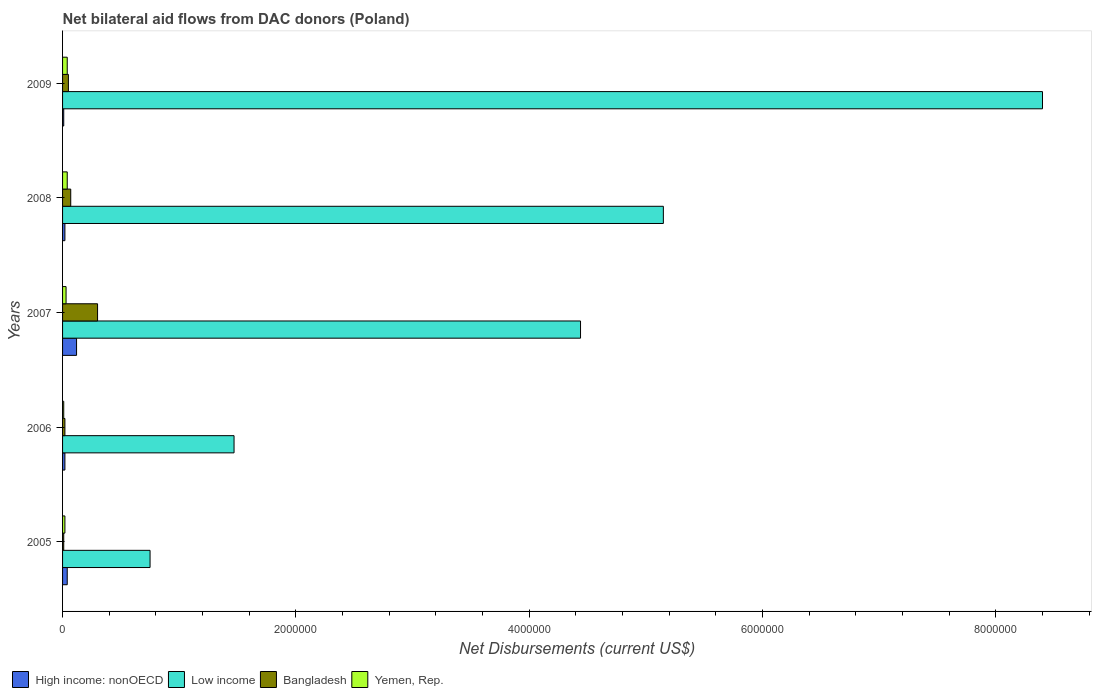How many different coloured bars are there?
Provide a short and direct response. 4. How many groups of bars are there?
Ensure brevity in your answer.  5. Are the number of bars per tick equal to the number of legend labels?
Provide a succinct answer. Yes. Are the number of bars on each tick of the Y-axis equal?
Your answer should be compact. Yes. How many bars are there on the 2nd tick from the bottom?
Your response must be concise. 4. What is the label of the 2nd group of bars from the top?
Offer a very short reply. 2008. In how many cases, is the number of bars for a given year not equal to the number of legend labels?
Provide a succinct answer. 0. What is the net bilateral aid flows in High income: nonOECD in 2005?
Offer a very short reply. 4.00e+04. Across all years, what is the maximum net bilateral aid flows in Low income?
Keep it short and to the point. 8.40e+06. Across all years, what is the minimum net bilateral aid flows in Low income?
Ensure brevity in your answer.  7.50e+05. In which year was the net bilateral aid flows in Bangladesh maximum?
Provide a succinct answer. 2007. What is the total net bilateral aid flows in Bangladesh in the graph?
Provide a succinct answer. 4.50e+05. What is the difference between the net bilateral aid flows in Yemen, Rep. in 2005 and that in 2008?
Your answer should be compact. -2.00e+04. What is the average net bilateral aid flows in High income: nonOECD per year?
Offer a terse response. 4.20e+04. In the year 2006, what is the difference between the net bilateral aid flows in High income: nonOECD and net bilateral aid flows in Low income?
Your answer should be compact. -1.45e+06. In how many years, is the net bilateral aid flows in Yemen, Rep. greater than 2000000 US$?
Provide a short and direct response. 0. Is the difference between the net bilateral aid flows in High income: nonOECD in 2006 and 2007 greater than the difference between the net bilateral aid flows in Low income in 2006 and 2007?
Make the answer very short. Yes. What is the difference between the highest and the lowest net bilateral aid flows in Low income?
Your response must be concise. 7.65e+06. Is the sum of the net bilateral aid flows in High income: nonOECD in 2006 and 2009 greater than the maximum net bilateral aid flows in Yemen, Rep. across all years?
Offer a terse response. No. Is it the case that in every year, the sum of the net bilateral aid flows in Yemen, Rep. and net bilateral aid flows in Bangladesh is greater than the sum of net bilateral aid flows in Low income and net bilateral aid flows in High income: nonOECD?
Provide a succinct answer. No. What does the 4th bar from the top in 2005 represents?
Make the answer very short. High income: nonOECD. What does the 1st bar from the bottom in 2005 represents?
Provide a succinct answer. High income: nonOECD. Is it the case that in every year, the sum of the net bilateral aid flows in High income: nonOECD and net bilateral aid flows in Low income is greater than the net bilateral aid flows in Bangladesh?
Keep it short and to the point. Yes. Are the values on the major ticks of X-axis written in scientific E-notation?
Offer a terse response. No. Does the graph contain grids?
Provide a succinct answer. No. How are the legend labels stacked?
Offer a very short reply. Horizontal. What is the title of the graph?
Your answer should be very brief. Net bilateral aid flows from DAC donors (Poland). What is the label or title of the X-axis?
Offer a very short reply. Net Disbursements (current US$). What is the label or title of the Y-axis?
Keep it short and to the point. Years. What is the Net Disbursements (current US$) of High income: nonOECD in 2005?
Keep it short and to the point. 4.00e+04. What is the Net Disbursements (current US$) in Low income in 2005?
Provide a succinct answer. 7.50e+05. What is the Net Disbursements (current US$) of Bangladesh in 2005?
Offer a very short reply. 10000. What is the Net Disbursements (current US$) of Yemen, Rep. in 2005?
Provide a succinct answer. 2.00e+04. What is the Net Disbursements (current US$) in High income: nonOECD in 2006?
Your response must be concise. 2.00e+04. What is the Net Disbursements (current US$) of Low income in 2006?
Your response must be concise. 1.47e+06. What is the Net Disbursements (current US$) of Yemen, Rep. in 2006?
Your answer should be compact. 10000. What is the Net Disbursements (current US$) in High income: nonOECD in 2007?
Give a very brief answer. 1.20e+05. What is the Net Disbursements (current US$) of Low income in 2007?
Your answer should be very brief. 4.44e+06. What is the Net Disbursements (current US$) in High income: nonOECD in 2008?
Provide a succinct answer. 2.00e+04. What is the Net Disbursements (current US$) in Low income in 2008?
Ensure brevity in your answer.  5.15e+06. What is the Net Disbursements (current US$) of Bangladesh in 2008?
Your answer should be very brief. 7.00e+04. What is the Net Disbursements (current US$) of High income: nonOECD in 2009?
Ensure brevity in your answer.  10000. What is the Net Disbursements (current US$) in Low income in 2009?
Make the answer very short. 8.40e+06. What is the Net Disbursements (current US$) of Yemen, Rep. in 2009?
Provide a short and direct response. 4.00e+04. Across all years, what is the maximum Net Disbursements (current US$) of High income: nonOECD?
Make the answer very short. 1.20e+05. Across all years, what is the maximum Net Disbursements (current US$) of Low income?
Your answer should be compact. 8.40e+06. Across all years, what is the maximum Net Disbursements (current US$) of Bangladesh?
Your response must be concise. 3.00e+05. Across all years, what is the minimum Net Disbursements (current US$) of High income: nonOECD?
Your response must be concise. 10000. Across all years, what is the minimum Net Disbursements (current US$) in Low income?
Give a very brief answer. 7.50e+05. Across all years, what is the minimum Net Disbursements (current US$) of Bangladesh?
Your response must be concise. 10000. Across all years, what is the minimum Net Disbursements (current US$) of Yemen, Rep.?
Provide a succinct answer. 10000. What is the total Net Disbursements (current US$) in High income: nonOECD in the graph?
Provide a succinct answer. 2.10e+05. What is the total Net Disbursements (current US$) in Low income in the graph?
Give a very brief answer. 2.02e+07. What is the difference between the Net Disbursements (current US$) in High income: nonOECD in 2005 and that in 2006?
Provide a short and direct response. 2.00e+04. What is the difference between the Net Disbursements (current US$) in Low income in 2005 and that in 2006?
Offer a very short reply. -7.20e+05. What is the difference between the Net Disbursements (current US$) of Bangladesh in 2005 and that in 2006?
Give a very brief answer. -10000. What is the difference between the Net Disbursements (current US$) in Yemen, Rep. in 2005 and that in 2006?
Give a very brief answer. 10000. What is the difference between the Net Disbursements (current US$) in High income: nonOECD in 2005 and that in 2007?
Your answer should be very brief. -8.00e+04. What is the difference between the Net Disbursements (current US$) of Low income in 2005 and that in 2007?
Give a very brief answer. -3.69e+06. What is the difference between the Net Disbursements (current US$) in Yemen, Rep. in 2005 and that in 2007?
Keep it short and to the point. -10000. What is the difference between the Net Disbursements (current US$) of High income: nonOECD in 2005 and that in 2008?
Your answer should be very brief. 2.00e+04. What is the difference between the Net Disbursements (current US$) of Low income in 2005 and that in 2008?
Make the answer very short. -4.40e+06. What is the difference between the Net Disbursements (current US$) of Bangladesh in 2005 and that in 2008?
Ensure brevity in your answer.  -6.00e+04. What is the difference between the Net Disbursements (current US$) of Yemen, Rep. in 2005 and that in 2008?
Your answer should be compact. -2.00e+04. What is the difference between the Net Disbursements (current US$) in Low income in 2005 and that in 2009?
Ensure brevity in your answer.  -7.65e+06. What is the difference between the Net Disbursements (current US$) in Yemen, Rep. in 2005 and that in 2009?
Your answer should be very brief. -2.00e+04. What is the difference between the Net Disbursements (current US$) in High income: nonOECD in 2006 and that in 2007?
Your answer should be compact. -1.00e+05. What is the difference between the Net Disbursements (current US$) of Low income in 2006 and that in 2007?
Keep it short and to the point. -2.97e+06. What is the difference between the Net Disbursements (current US$) of Bangladesh in 2006 and that in 2007?
Keep it short and to the point. -2.80e+05. What is the difference between the Net Disbursements (current US$) of Yemen, Rep. in 2006 and that in 2007?
Ensure brevity in your answer.  -2.00e+04. What is the difference between the Net Disbursements (current US$) in High income: nonOECD in 2006 and that in 2008?
Your answer should be very brief. 0. What is the difference between the Net Disbursements (current US$) of Low income in 2006 and that in 2008?
Keep it short and to the point. -3.68e+06. What is the difference between the Net Disbursements (current US$) in Bangladesh in 2006 and that in 2008?
Keep it short and to the point. -5.00e+04. What is the difference between the Net Disbursements (current US$) of Yemen, Rep. in 2006 and that in 2008?
Your answer should be compact. -3.00e+04. What is the difference between the Net Disbursements (current US$) in Low income in 2006 and that in 2009?
Make the answer very short. -6.93e+06. What is the difference between the Net Disbursements (current US$) of Bangladesh in 2006 and that in 2009?
Make the answer very short. -3.00e+04. What is the difference between the Net Disbursements (current US$) of Yemen, Rep. in 2006 and that in 2009?
Offer a terse response. -3.00e+04. What is the difference between the Net Disbursements (current US$) in Low income in 2007 and that in 2008?
Provide a short and direct response. -7.10e+05. What is the difference between the Net Disbursements (current US$) of Yemen, Rep. in 2007 and that in 2008?
Give a very brief answer. -10000. What is the difference between the Net Disbursements (current US$) of Low income in 2007 and that in 2009?
Ensure brevity in your answer.  -3.96e+06. What is the difference between the Net Disbursements (current US$) in Bangladesh in 2007 and that in 2009?
Offer a very short reply. 2.50e+05. What is the difference between the Net Disbursements (current US$) in Yemen, Rep. in 2007 and that in 2009?
Ensure brevity in your answer.  -10000. What is the difference between the Net Disbursements (current US$) in High income: nonOECD in 2008 and that in 2009?
Your answer should be compact. 10000. What is the difference between the Net Disbursements (current US$) of Low income in 2008 and that in 2009?
Your answer should be compact. -3.25e+06. What is the difference between the Net Disbursements (current US$) in High income: nonOECD in 2005 and the Net Disbursements (current US$) in Low income in 2006?
Provide a short and direct response. -1.43e+06. What is the difference between the Net Disbursements (current US$) of Low income in 2005 and the Net Disbursements (current US$) of Bangladesh in 2006?
Offer a terse response. 7.30e+05. What is the difference between the Net Disbursements (current US$) of Low income in 2005 and the Net Disbursements (current US$) of Yemen, Rep. in 2006?
Keep it short and to the point. 7.40e+05. What is the difference between the Net Disbursements (current US$) in Bangladesh in 2005 and the Net Disbursements (current US$) in Yemen, Rep. in 2006?
Provide a short and direct response. 0. What is the difference between the Net Disbursements (current US$) of High income: nonOECD in 2005 and the Net Disbursements (current US$) of Low income in 2007?
Your answer should be compact. -4.40e+06. What is the difference between the Net Disbursements (current US$) of High income: nonOECD in 2005 and the Net Disbursements (current US$) of Bangladesh in 2007?
Give a very brief answer. -2.60e+05. What is the difference between the Net Disbursements (current US$) of Low income in 2005 and the Net Disbursements (current US$) of Yemen, Rep. in 2007?
Your response must be concise. 7.20e+05. What is the difference between the Net Disbursements (current US$) in Bangladesh in 2005 and the Net Disbursements (current US$) in Yemen, Rep. in 2007?
Offer a terse response. -2.00e+04. What is the difference between the Net Disbursements (current US$) in High income: nonOECD in 2005 and the Net Disbursements (current US$) in Low income in 2008?
Your response must be concise. -5.11e+06. What is the difference between the Net Disbursements (current US$) of High income: nonOECD in 2005 and the Net Disbursements (current US$) of Yemen, Rep. in 2008?
Keep it short and to the point. 0. What is the difference between the Net Disbursements (current US$) in Low income in 2005 and the Net Disbursements (current US$) in Bangladesh in 2008?
Provide a short and direct response. 6.80e+05. What is the difference between the Net Disbursements (current US$) of Low income in 2005 and the Net Disbursements (current US$) of Yemen, Rep. in 2008?
Your response must be concise. 7.10e+05. What is the difference between the Net Disbursements (current US$) of Bangladesh in 2005 and the Net Disbursements (current US$) of Yemen, Rep. in 2008?
Provide a succinct answer. -3.00e+04. What is the difference between the Net Disbursements (current US$) in High income: nonOECD in 2005 and the Net Disbursements (current US$) in Low income in 2009?
Your answer should be compact. -8.36e+06. What is the difference between the Net Disbursements (current US$) in Low income in 2005 and the Net Disbursements (current US$) in Bangladesh in 2009?
Offer a very short reply. 7.00e+05. What is the difference between the Net Disbursements (current US$) of Low income in 2005 and the Net Disbursements (current US$) of Yemen, Rep. in 2009?
Offer a terse response. 7.10e+05. What is the difference between the Net Disbursements (current US$) of Bangladesh in 2005 and the Net Disbursements (current US$) of Yemen, Rep. in 2009?
Your answer should be very brief. -3.00e+04. What is the difference between the Net Disbursements (current US$) in High income: nonOECD in 2006 and the Net Disbursements (current US$) in Low income in 2007?
Offer a very short reply. -4.42e+06. What is the difference between the Net Disbursements (current US$) in High income: nonOECD in 2006 and the Net Disbursements (current US$) in Bangladesh in 2007?
Your answer should be very brief. -2.80e+05. What is the difference between the Net Disbursements (current US$) of High income: nonOECD in 2006 and the Net Disbursements (current US$) of Yemen, Rep. in 2007?
Offer a very short reply. -10000. What is the difference between the Net Disbursements (current US$) of Low income in 2006 and the Net Disbursements (current US$) of Bangladesh in 2007?
Provide a succinct answer. 1.17e+06. What is the difference between the Net Disbursements (current US$) of Low income in 2006 and the Net Disbursements (current US$) of Yemen, Rep. in 2007?
Provide a short and direct response. 1.44e+06. What is the difference between the Net Disbursements (current US$) in Bangladesh in 2006 and the Net Disbursements (current US$) in Yemen, Rep. in 2007?
Your answer should be very brief. -10000. What is the difference between the Net Disbursements (current US$) of High income: nonOECD in 2006 and the Net Disbursements (current US$) of Low income in 2008?
Make the answer very short. -5.13e+06. What is the difference between the Net Disbursements (current US$) in High income: nonOECD in 2006 and the Net Disbursements (current US$) in Bangladesh in 2008?
Your answer should be compact. -5.00e+04. What is the difference between the Net Disbursements (current US$) in High income: nonOECD in 2006 and the Net Disbursements (current US$) in Yemen, Rep. in 2008?
Your answer should be compact. -2.00e+04. What is the difference between the Net Disbursements (current US$) of Low income in 2006 and the Net Disbursements (current US$) of Bangladesh in 2008?
Make the answer very short. 1.40e+06. What is the difference between the Net Disbursements (current US$) of Low income in 2006 and the Net Disbursements (current US$) of Yemen, Rep. in 2008?
Give a very brief answer. 1.43e+06. What is the difference between the Net Disbursements (current US$) of High income: nonOECD in 2006 and the Net Disbursements (current US$) of Low income in 2009?
Your response must be concise. -8.38e+06. What is the difference between the Net Disbursements (current US$) of High income: nonOECD in 2006 and the Net Disbursements (current US$) of Bangladesh in 2009?
Provide a succinct answer. -3.00e+04. What is the difference between the Net Disbursements (current US$) of Low income in 2006 and the Net Disbursements (current US$) of Bangladesh in 2009?
Make the answer very short. 1.42e+06. What is the difference between the Net Disbursements (current US$) in Low income in 2006 and the Net Disbursements (current US$) in Yemen, Rep. in 2009?
Your answer should be very brief. 1.43e+06. What is the difference between the Net Disbursements (current US$) in High income: nonOECD in 2007 and the Net Disbursements (current US$) in Low income in 2008?
Provide a short and direct response. -5.03e+06. What is the difference between the Net Disbursements (current US$) in High income: nonOECD in 2007 and the Net Disbursements (current US$) in Yemen, Rep. in 2008?
Make the answer very short. 8.00e+04. What is the difference between the Net Disbursements (current US$) of Low income in 2007 and the Net Disbursements (current US$) of Bangladesh in 2008?
Offer a very short reply. 4.37e+06. What is the difference between the Net Disbursements (current US$) of Low income in 2007 and the Net Disbursements (current US$) of Yemen, Rep. in 2008?
Keep it short and to the point. 4.40e+06. What is the difference between the Net Disbursements (current US$) in High income: nonOECD in 2007 and the Net Disbursements (current US$) in Low income in 2009?
Keep it short and to the point. -8.28e+06. What is the difference between the Net Disbursements (current US$) in High income: nonOECD in 2007 and the Net Disbursements (current US$) in Bangladesh in 2009?
Make the answer very short. 7.00e+04. What is the difference between the Net Disbursements (current US$) of High income: nonOECD in 2007 and the Net Disbursements (current US$) of Yemen, Rep. in 2009?
Your answer should be very brief. 8.00e+04. What is the difference between the Net Disbursements (current US$) of Low income in 2007 and the Net Disbursements (current US$) of Bangladesh in 2009?
Provide a succinct answer. 4.39e+06. What is the difference between the Net Disbursements (current US$) in Low income in 2007 and the Net Disbursements (current US$) in Yemen, Rep. in 2009?
Offer a terse response. 4.40e+06. What is the difference between the Net Disbursements (current US$) of High income: nonOECD in 2008 and the Net Disbursements (current US$) of Low income in 2009?
Your response must be concise. -8.38e+06. What is the difference between the Net Disbursements (current US$) of Low income in 2008 and the Net Disbursements (current US$) of Bangladesh in 2009?
Your answer should be very brief. 5.10e+06. What is the difference between the Net Disbursements (current US$) in Low income in 2008 and the Net Disbursements (current US$) in Yemen, Rep. in 2009?
Your answer should be very brief. 5.11e+06. What is the average Net Disbursements (current US$) in High income: nonOECD per year?
Give a very brief answer. 4.20e+04. What is the average Net Disbursements (current US$) of Low income per year?
Offer a very short reply. 4.04e+06. What is the average Net Disbursements (current US$) in Yemen, Rep. per year?
Make the answer very short. 2.80e+04. In the year 2005, what is the difference between the Net Disbursements (current US$) in High income: nonOECD and Net Disbursements (current US$) in Low income?
Offer a terse response. -7.10e+05. In the year 2005, what is the difference between the Net Disbursements (current US$) in Low income and Net Disbursements (current US$) in Bangladesh?
Give a very brief answer. 7.40e+05. In the year 2005, what is the difference between the Net Disbursements (current US$) of Low income and Net Disbursements (current US$) of Yemen, Rep.?
Your answer should be compact. 7.30e+05. In the year 2005, what is the difference between the Net Disbursements (current US$) in Bangladesh and Net Disbursements (current US$) in Yemen, Rep.?
Your answer should be very brief. -10000. In the year 2006, what is the difference between the Net Disbursements (current US$) in High income: nonOECD and Net Disbursements (current US$) in Low income?
Your answer should be very brief. -1.45e+06. In the year 2006, what is the difference between the Net Disbursements (current US$) in High income: nonOECD and Net Disbursements (current US$) in Bangladesh?
Your answer should be compact. 0. In the year 2006, what is the difference between the Net Disbursements (current US$) in High income: nonOECD and Net Disbursements (current US$) in Yemen, Rep.?
Keep it short and to the point. 10000. In the year 2006, what is the difference between the Net Disbursements (current US$) of Low income and Net Disbursements (current US$) of Bangladesh?
Your answer should be compact. 1.45e+06. In the year 2006, what is the difference between the Net Disbursements (current US$) in Low income and Net Disbursements (current US$) in Yemen, Rep.?
Keep it short and to the point. 1.46e+06. In the year 2006, what is the difference between the Net Disbursements (current US$) of Bangladesh and Net Disbursements (current US$) of Yemen, Rep.?
Ensure brevity in your answer.  10000. In the year 2007, what is the difference between the Net Disbursements (current US$) in High income: nonOECD and Net Disbursements (current US$) in Low income?
Give a very brief answer. -4.32e+06. In the year 2007, what is the difference between the Net Disbursements (current US$) in Low income and Net Disbursements (current US$) in Bangladesh?
Provide a succinct answer. 4.14e+06. In the year 2007, what is the difference between the Net Disbursements (current US$) of Low income and Net Disbursements (current US$) of Yemen, Rep.?
Offer a terse response. 4.41e+06. In the year 2008, what is the difference between the Net Disbursements (current US$) in High income: nonOECD and Net Disbursements (current US$) in Low income?
Give a very brief answer. -5.13e+06. In the year 2008, what is the difference between the Net Disbursements (current US$) of High income: nonOECD and Net Disbursements (current US$) of Yemen, Rep.?
Provide a short and direct response. -2.00e+04. In the year 2008, what is the difference between the Net Disbursements (current US$) of Low income and Net Disbursements (current US$) of Bangladesh?
Offer a terse response. 5.08e+06. In the year 2008, what is the difference between the Net Disbursements (current US$) of Low income and Net Disbursements (current US$) of Yemen, Rep.?
Offer a very short reply. 5.11e+06. In the year 2009, what is the difference between the Net Disbursements (current US$) of High income: nonOECD and Net Disbursements (current US$) of Low income?
Give a very brief answer. -8.39e+06. In the year 2009, what is the difference between the Net Disbursements (current US$) of High income: nonOECD and Net Disbursements (current US$) of Yemen, Rep.?
Ensure brevity in your answer.  -3.00e+04. In the year 2009, what is the difference between the Net Disbursements (current US$) in Low income and Net Disbursements (current US$) in Bangladesh?
Offer a very short reply. 8.35e+06. In the year 2009, what is the difference between the Net Disbursements (current US$) of Low income and Net Disbursements (current US$) of Yemen, Rep.?
Provide a succinct answer. 8.36e+06. What is the ratio of the Net Disbursements (current US$) of High income: nonOECD in 2005 to that in 2006?
Ensure brevity in your answer.  2. What is the ratio of the Net Disbursements (current US$) of Low income in 2005 to that in 2006?
Ensure brevity in your answer.  0.51. What is the ratio of the Net Disbursements (current US$) of High income: nonOECD in 2005 to that in 2007?
Ensure brevity in your answer.  0.33. What is the ratio of the Net Disbursements (current US$) in Low income in 2005 to that in 2007?
Your answer should be very brief. 0.17. What is the ratio of the Net Disbursements (current US$) in Yemen, Rep. in 2005 to that in 2007?
Make the answer very short. 0.67. What is the ratio of the Net Disbursements (current US$) of Low income in 2005 to that in 2008?
Ensure brevity in your answer.  0.15. What is the ratio of the Net Disbursements (current US$) of Bangladesh in 2005 to that in 2008?
Provide a succinct answer. 0.14. What is the ratio of the Net Disbursements (current US$) in Yemen, Rep. in 2005 to that in 2008?
Keep it short and to the point. 0.5. What is the ratio of the Net Disbursements (current US$) in Low income in 2005 to that in 2009?
Make the answer very short. 0.09. What is the ratio of the Net Disbursements (current US$) in Bangladesh in 2005 to that in 2009?
Your answer should be compact. 0.2. What is the ratio of the Net Disbursements (current US$) in Yemen, Rep. in 2005 to that in 2009?
Offer a very short reply. 0.5. What is the ratio of the Net Disbursements (current US$) in Low income in 2006 to that in 2007?
Give a very brief answer. 0.33. What is the ratio of the Net Disbursements (current US$) in Bangladesh in 2006 to that in 2007?
Ensure brevity in your answer.  0.07. What is the ratio of the Net Disbursements (current US$) in Yemen, Rep. in 2006 to that in 2007?
Keep it short and to the point. 0.33. What is the ratio of the Net Disbursements (current US$) in High income: nonOECD in 2006 to that in 2008?
Your answer should be very brief. 1. What is the ratio of the Net Disbursements (current US$) in Low income in 2006 to that in 2008?
Provide a short and direct response. 0.29. What is the ratio of the Net Disbursements (current US$) in Bangladesh in 2006 to that in 2008?
Offer a terse response. 0.29. What is the ratio of the Net Disbursements (current US$) of Yemen, Rep. in 2006 to that in 2008?
Make the answer very short. 0.25. What is the ratio of the Net Disbursements (current US$) in High income: nonOECD in 2006 to that in 2009?
Keep it short and to the point. 2. What is the ratio of the Net Disbursements (current US$) of Low income in 2006 to that in 2009?
Ensure brevity in your answer.  0.17. What is the ratio of the Net Disbursements (current US$) of Bangladesh in 2006 to that in 2009?
Your answer should be very brief. 0.4. What is the ratio of the Net Disbursements (current US$) of High income: nonOECD in 2007 to that in 2008?
Your answer should be compact. 6. What is the ratio of the Net Disbursements (current US$) in Low income in 2007 to that in 2008?
Offer a terse response. 0.86. What is the ratio of the Net Disbursements (current US$) of Bangladesh in 2007 to that in 2008?
Keep it short and to the point. 4.29. What is the ratio of the Net Disbursements (current US$) of Yemen, Rep. in 2007 to that in 2008?
Provide a short and direct response. 0.75. What is the ratio of the Net Disbursements (current US$) in Low income in 2007 to that in 2009?
Make the answer very short. 0.53. What is the ratio of the Net Disbursements (current US$) of High income: nonOECD in 2008 to that in 2009?
Your answer should be compact. 2. What is the ratio of the Net Disbursements (current US$) in Low income in 2008 to that in 2009?
Make the answer very short. 0.61. What is the ratio of the Net Disbursements (current US$) in Bangladesh in 2008 to that in 2009?
Offer a very short reply. 1.4. What is the ratio of the Net Disbursements (current US$) in Yemen, Rep. in 2008 to that in 2009?
Keep it short and to the point. 1. What is the difference between the highest and the second highest Net Disbursements (current US$) in Low income?
Your answer should be compact. 3.25e+06. What is the difference between the highest and the second highest Net Disbursements (current US$) of Bangladesh?
Ensure brevity in your answer.  2.30e+05. What is the difference between the highest and the second highest Net Disbursements (current US$) of Yemen, Rep.?
Offer a terse response. 0. What is the difference between the highest and the lowest Net Disbursements (current US$) of Low income?
Provide a short and direct response. 7.65e+06. 